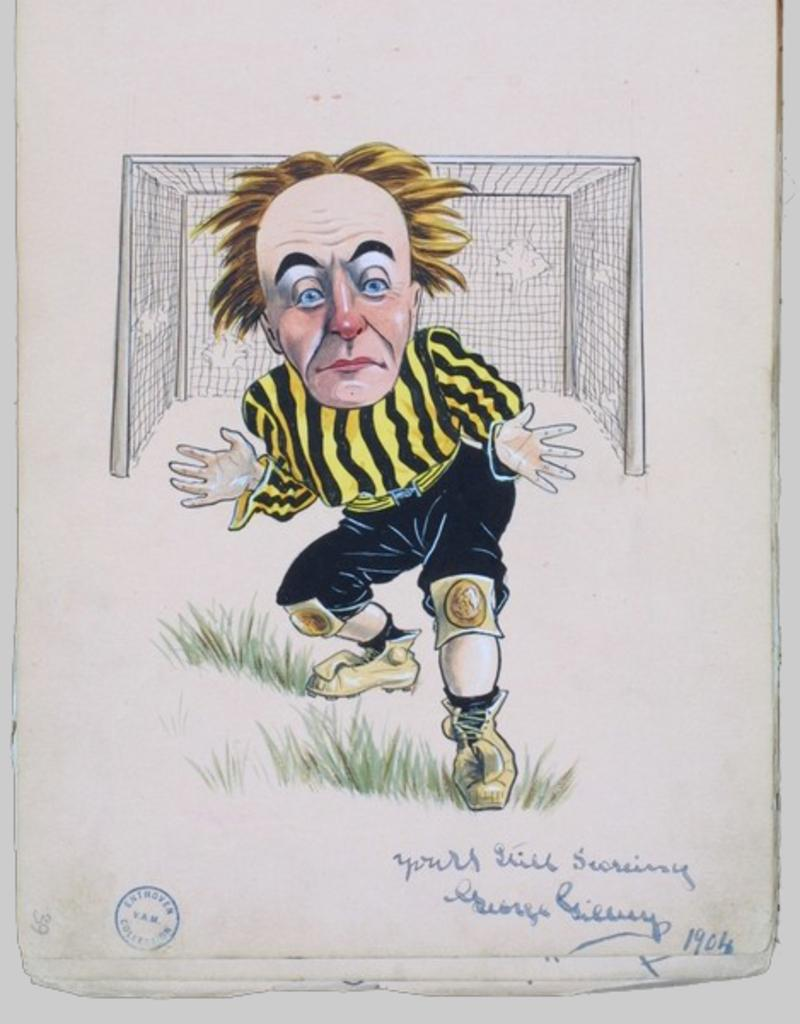What is the main subject of the image? There is a depiction of a person in the center of the image. What else can be seen in the image besides the person? There is a net in the image. Is there any text present in the image? Yes, there is some text at the bottom of the image. How many men are playing on the team in the image? There is no team or men present in the image; it only depicts a person and a net. What type of injury is the person on the wrist in the image? There is no injury or wrist visible in the image; it only depicts a person and a net. 